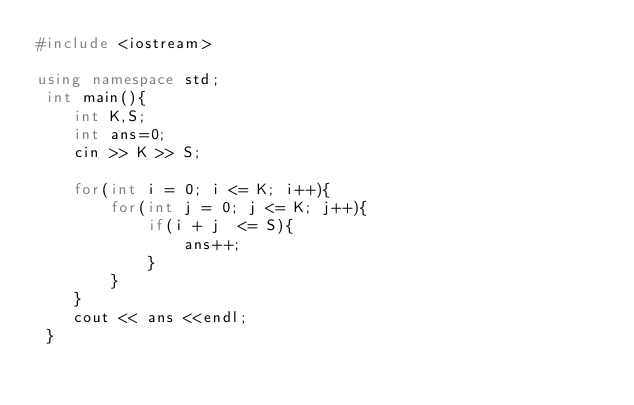Convert code to text. <code><loc_0><loc_0><loc_500><loc_500><_C++_>#include <iostream>

using namespace std;
 int main(){
    int K,S;
    int ans=0;
    cin >> K >> S;

    for(int i = 0; i <= K; i++){
        for(int j = 0; j <= K; j++){
            if(i + j  <= S){
                ans++;
            } 
        }  
    }
    cout << ans <<endl;     
 }</code> 